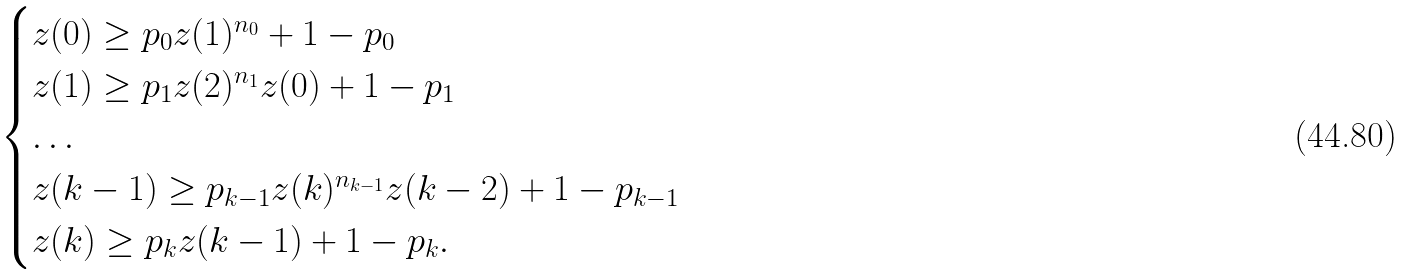Convert formula to latex. <formula><loc_0><loc_0><loc_500><loc_500>\begin{cases} z ( 0 ) \geq p _ { 0 } z ( 1 ) ^ { n _ { 0 } } + 1 - p _ { 0 } \\ z ( 1 ) \geq p _ { 1 } z ( 2 ) ^ { n _ { 1 } } z ( 0 ) + 1 - p _ { 1 } \\ \dots \\ z ( k - 1 ) \geq p _ { k - 1 } z ( k ) ^ { n _ { k - 1 } } z ( k - 2 ) + 1 - p _ { k - 1 } \\ z ( k ) \geq p _ { k } z ( k - 1 ) + 1 - p _ { k } . \\ \end{cases}</formula> 